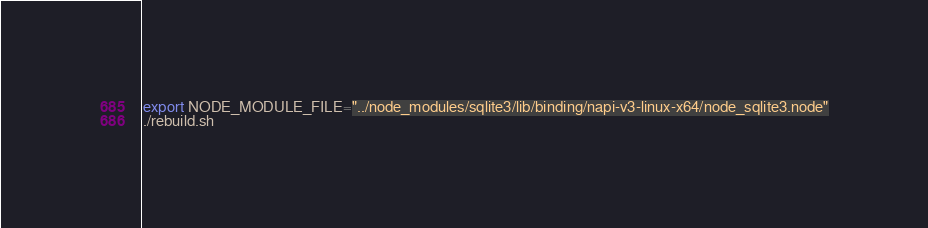<code> <loc_0><loc_0><loc_500><loc_500><_Bash_>export NODE_MODULE_FILE="../node_modules/sqlite3/lib/binding/napi-v3-linux-x64/node_sqlite3.node"
./rebuild.sh</code> 